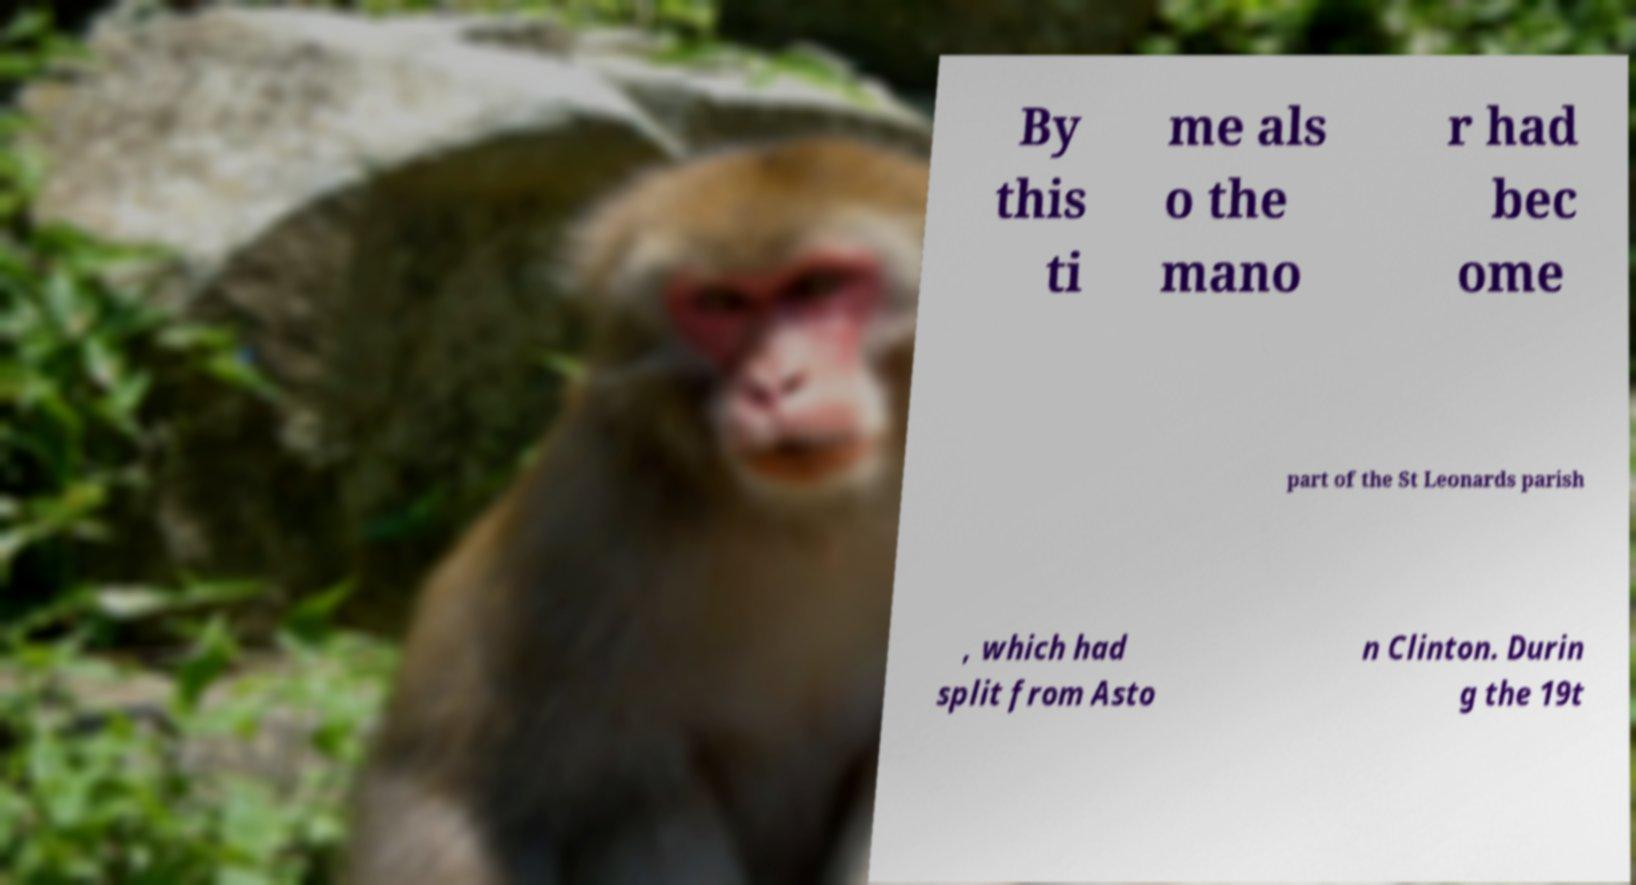I need the written content from this picture converted into text. Can you do that? By this ti me als o the mano r had bec ome part of the St Leonards parish , which had split from Asto n Clinton. Durin g the 19t 